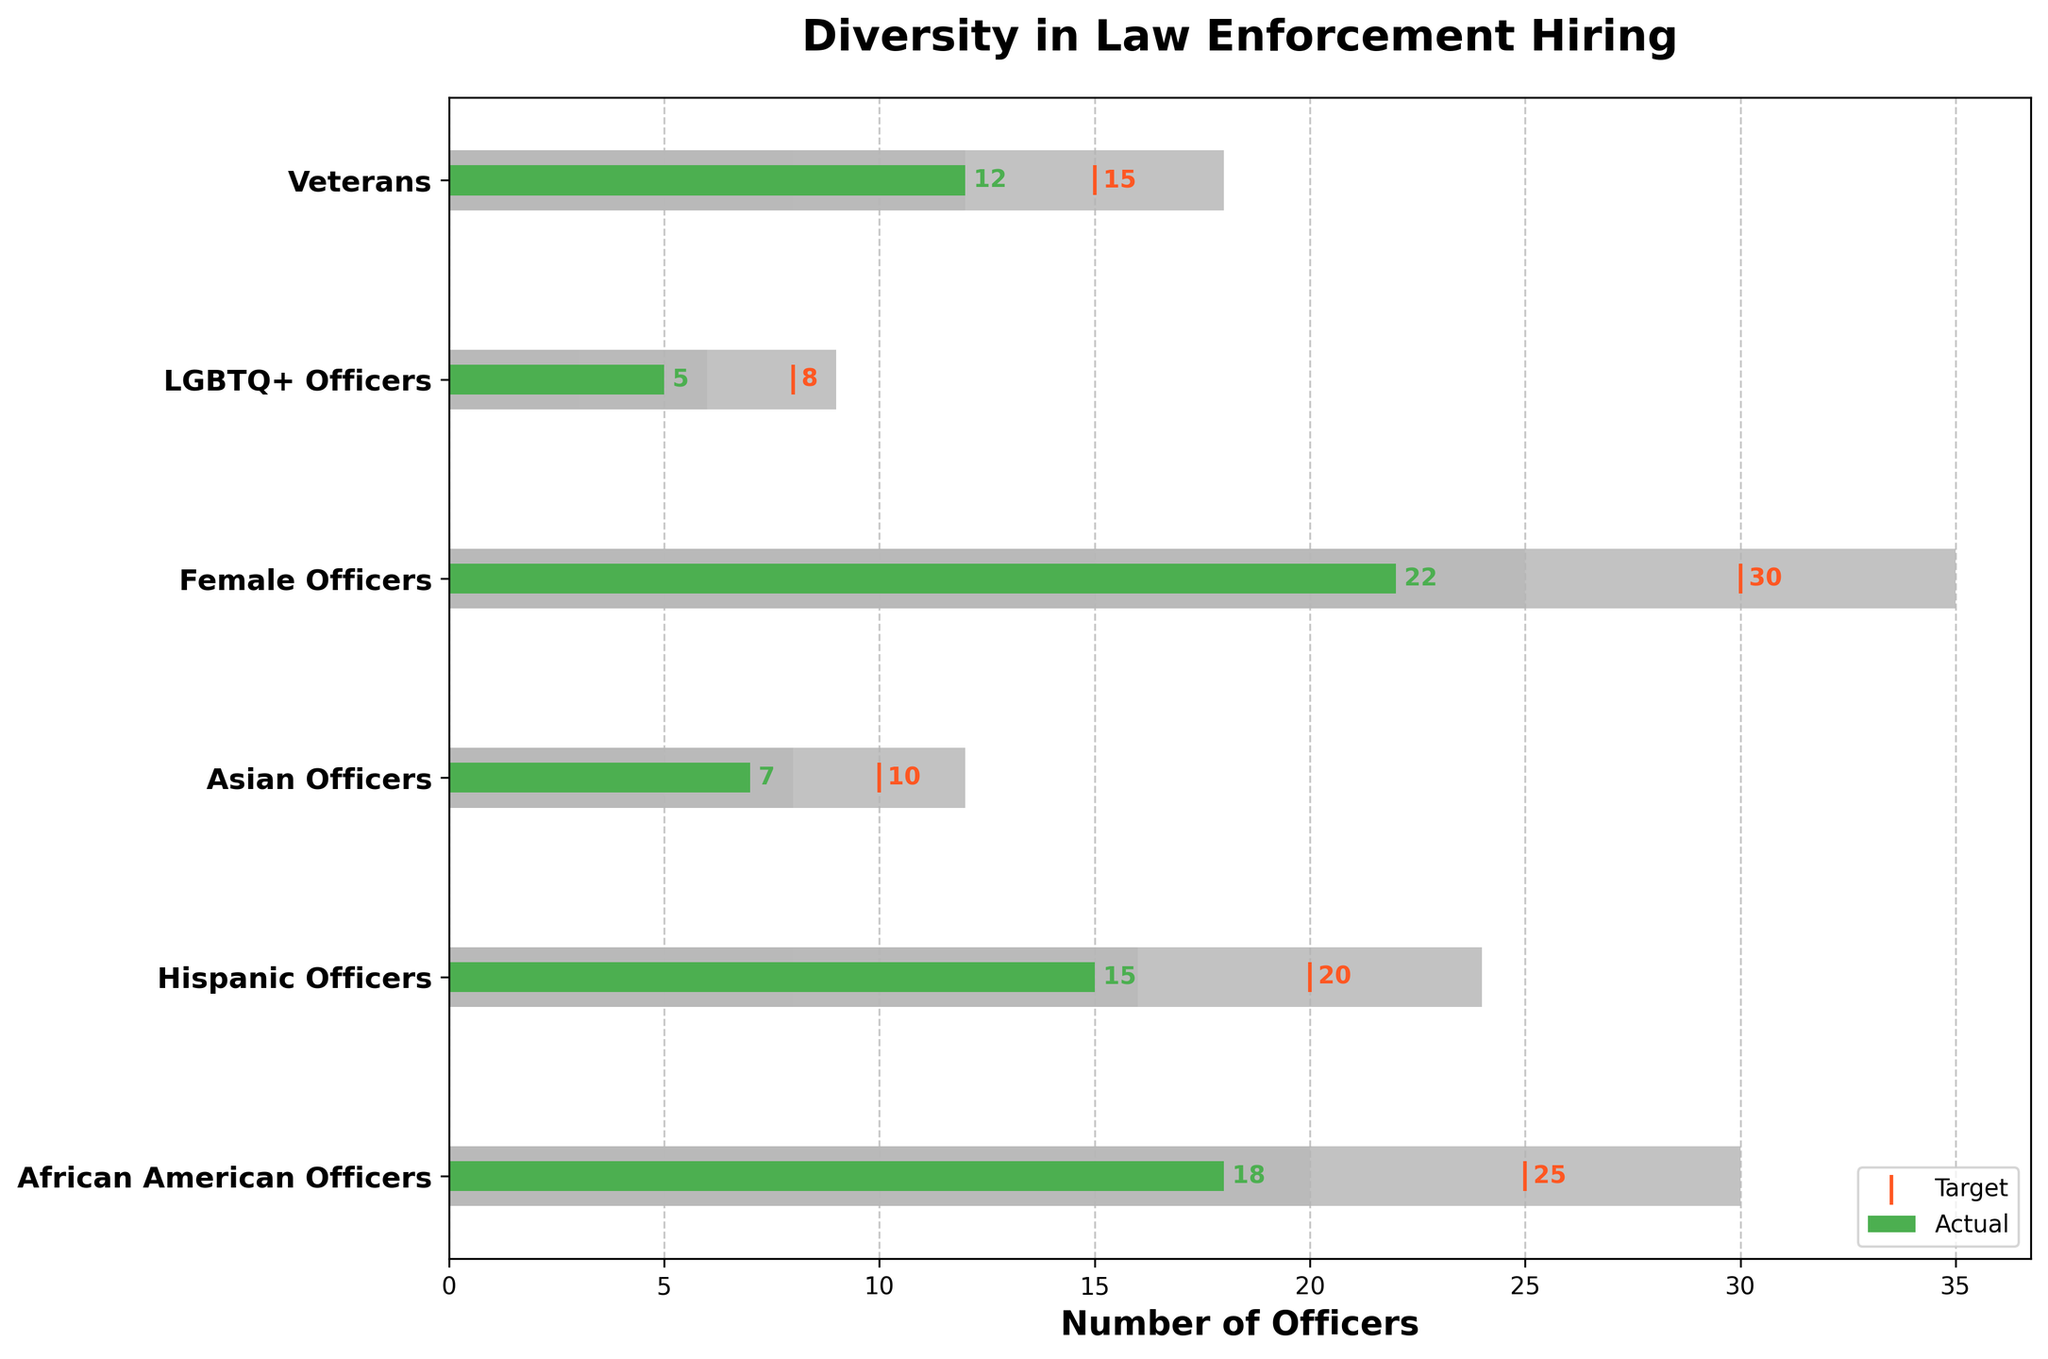What's the title of the chart? The title of the chart is located at the top and indicates the main subject of the plot.
Answer: Diversity in Law Enforcement Hiring How many categories are represented in the chart? The chart has a y-axis with labels for different categories. Count each category label to determine the total number.
Answer: 6 Which category's actual value is exactly half of its highest range value? Check the green bars and corresponding gray ranges. African American Officers have an actual value (18) which is half of its highest range value (30).
Answer: African American Officers What is the range for Asian Officers where the actual number falls in? The actual value for Asian Officers is 7. Identify which of the gray ranges this number falls into. For Asian Officers, the Range1 is 5, Range2 is 8, and Range3 is 12.
Answer: Range2 Which two categories have their actual values aligned with the value separating Range2 and Range3? For each category, check if the actual value matches the border between Range2 and Range3. Veterans have an actual value (12) which equals the border between Range2 (12) and Range3 (18).
Answer: Veterans Which category has the smallest actual value, and what is it? Look at the green bars and identify the shortest one. The shortest bar corresponds to LGBTQ+ Officers.
Answer: LGBTQ+ Officers, 5 Which categories have actual values exceeding Range2 but not reaching Range3? Identify categories where the green bar exceeds the value of Range2 but is less than Range3. African American Officers (18) and Hispanic Officers (15) fit this criterion.
Answer: African American Officers, Hispanic Officers 